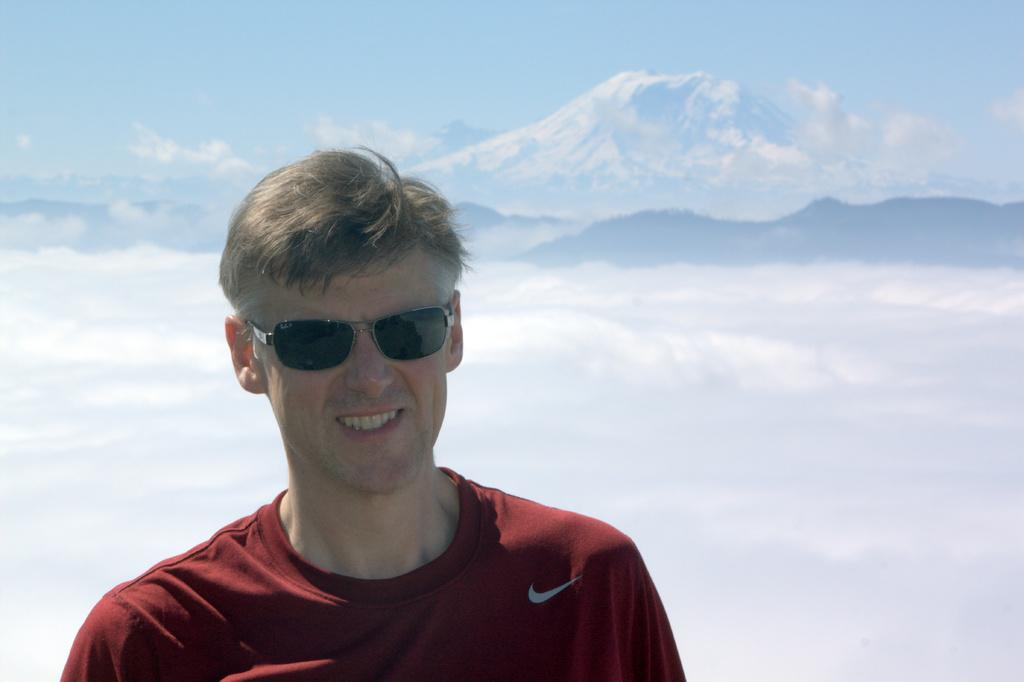Who is present in the image? There is a man in the image. What is the man standing in front of? The man is standing in front of ice mountains. What is the man's facial expression? The man is smiling. What type of sign can be seen on the ice mountains in the image? There are no signs visible on the ice mountains in the image. 